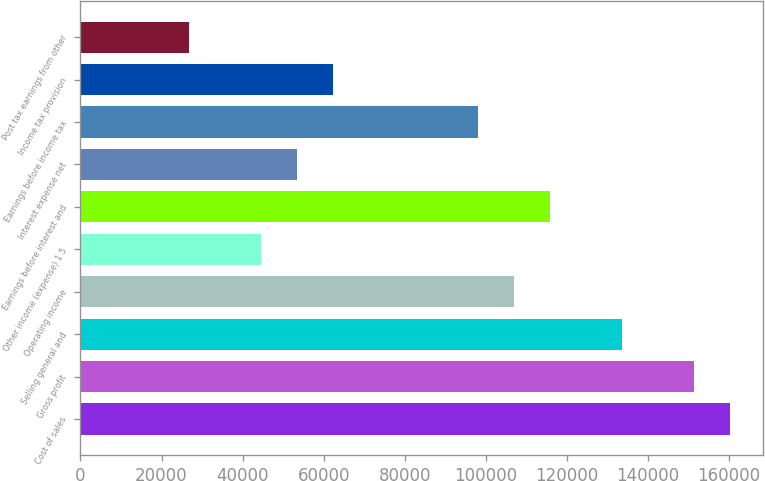Convert chart to OTSL. <chart><loc_0><loc_0><loc_500><loc_500><bar_chart><fcel>Cost of sales<fcel>Gross profit<fcel>Selling general and<fcel>Operating income<fcel>Other income (expense) 1 5<fcel>Earnings before interest and<fcel>Interest expense net<fcel>Earnings before income tax<fcel>Income tax provision<fcel>Post tax earnings from other<nl><fcel>160292<fcel>151387<fcel>133577<fcel>106862<fcel>44526.8<fcel>115767<fcel>53431.8<fcel>97957.1<fcel>62336.9<fcel>26716.7<nl></chart> 